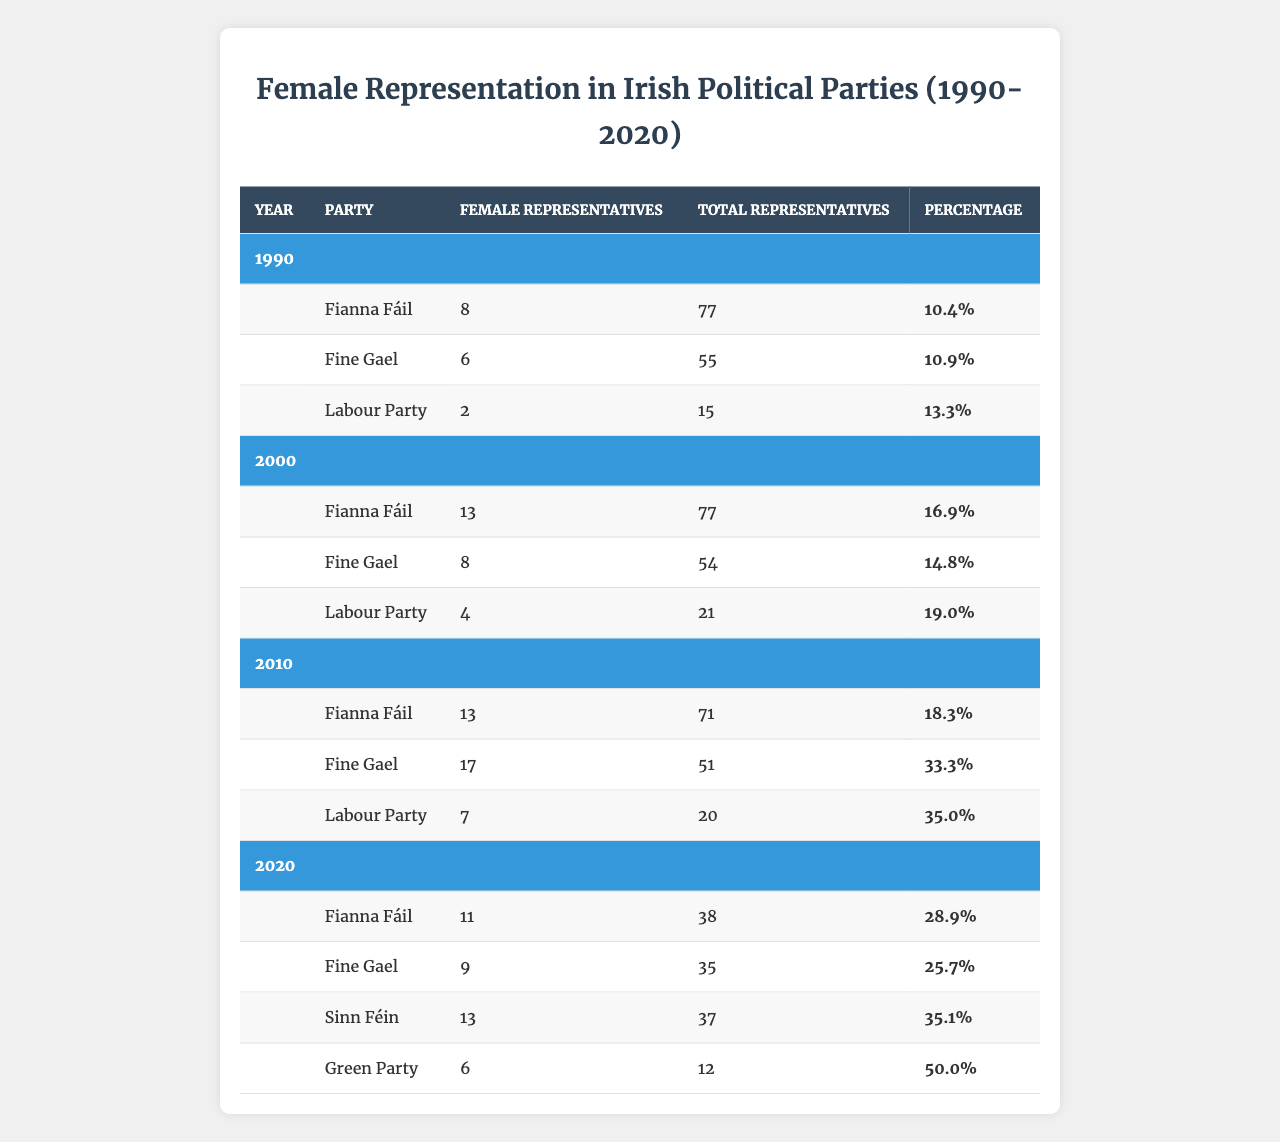What was the total number of female representatives from the Labour Party in 2010? According to the table, the Labour Party had 7 female representatives in 2010.
Answer: 7 Which party had the highest percentage of female representatives in 2020? In 2020, the Green Party had the highest percentage of female representatives at 50%.
Answer: Green Party What is the percentage increase of female representatives in Fianna Fáil from 1990 to 2000? In 1990, Fianna Fáil had 10.4% female representatives, and in 2000 it increased to 16.9%. The difference is 16.9% - 10.4% = 6.5%. Therefore, the percentage increase is 6.5%.
Answer: 6.5% Did Fine Gael have more than 15 female representatives in 2010? In 2010, Fine Gael had 17 female representatives, which is more than 15, confirming the statement is true.
Answer: Yes What is the average percentage of female representatives for all parties in 2000? For 2000, the percentages are Fianna Fáil: 16.9%, Fine Gael: 14.8%, and Labour Party: 19.0%. Adding these gives 16.9 + 14.8 + 19.0 = 50.7. There are three parties, so the average percentage is 50.7 / 3 = 16.9.
Answer: 16.9 How many total representatives did Sinn Féin have in 2020? Sinn Féin had 37 total representatives in 2020 as per the table.
Answer: 37 What was the trend in female representation for the Labour Party from 1990 to 2020? The Labour Party started with 13.3% in 1990, rose to 19.0% in 2000, dropped to 35.0% in 2010, and remained at 35.1% in 2020. Although there were fluctuations, it generally increased over the years, ending with a strong percentage in 2020.
Answer: Increasing overall Which party's percentage of female representatives decreased from 2010 to 2020? In 2020, Fianna Fáil percentage decreased from 18.3% in 2010 to 28.9% in 2020, showing a positive trend rather than a decrease. However, Fine Gael’s percentage dropped from 33.3% in 2010 to 25.7% in 2020 indicating a decrease.
Answer: Fine Gael What was the combined number of female representatives from all parties in 2020? In 2020, the female representatives were as follows: Fianna Fáil (11), Fine Gael (9), Sinn Féin (13), Green Party (6). Adding these gives 11 + 9 + 13 + 6 = 39.
Answer: 39 Which year saw the largest increase in the percentage of female representatives in the Labour Party? Comparing the Labour Party's percentages: 1990 (13.3%), 2000 (19.0%), 2010 (35.0%), 2020 (35.1%), the largest increase occurred between 2000 and 2010, from 19.0% to 35.0%, an increase of 16.0%.
Answer: 2000 to 2010 